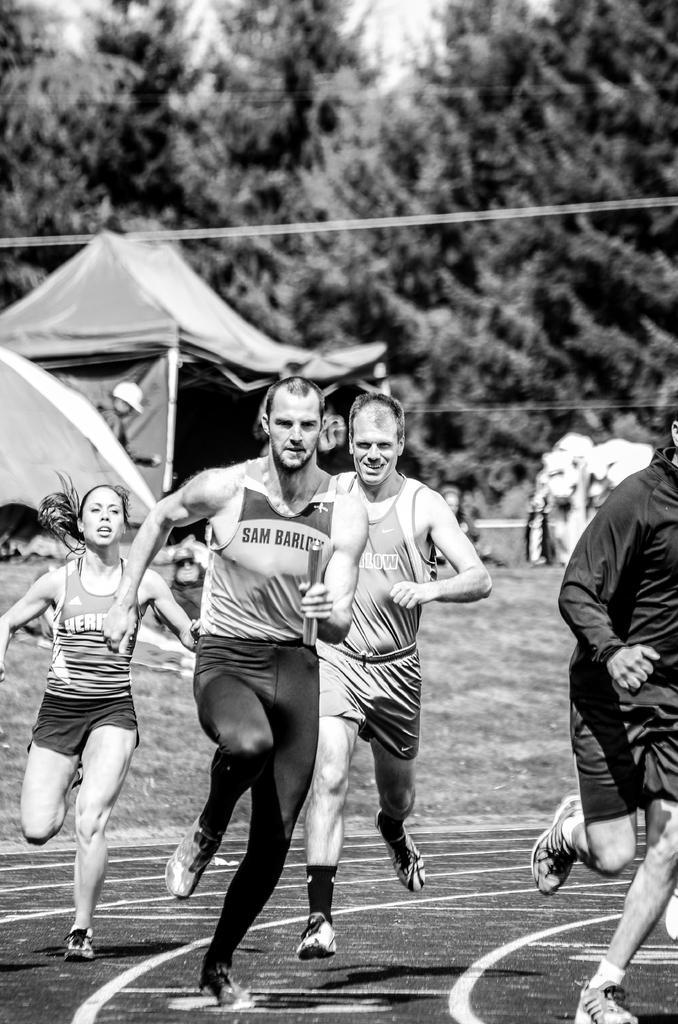How would you summarize this image in a sentence or two? This is a black and white image. In this image, we can see there are persons running on the ground, on which there are lines. In the background, there are persons, trees and sky. 